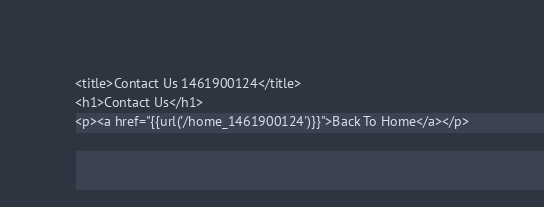Convert code to text. <code><loc_0><loc_0><loc_500><loc_500><_PHP_><title>Contact Us 1461900124</title>
<h1>Contact Us</h1>
<p><a href="{{url('/home_1461900124')}}">Back To Home</a></p></code> 